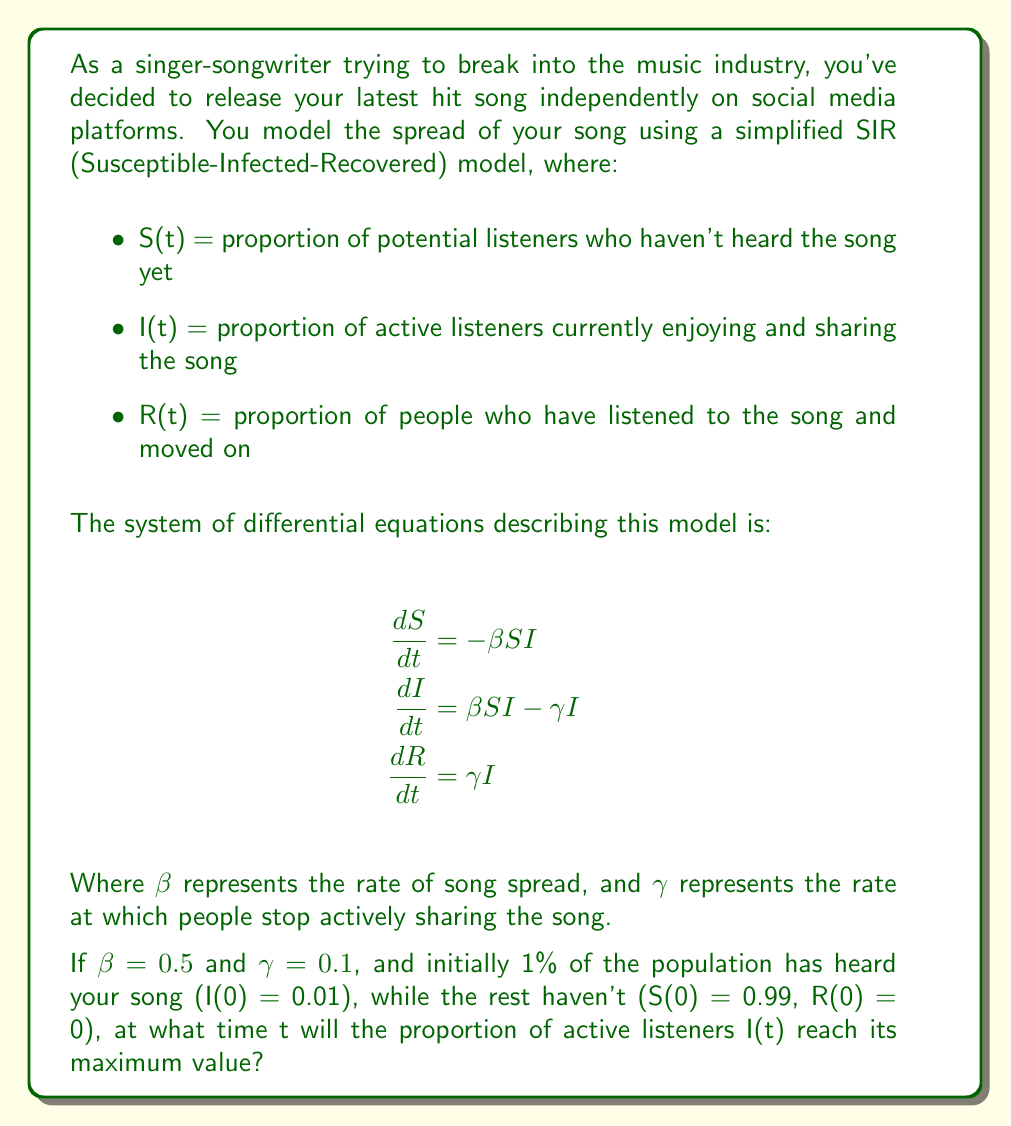Teach me how to tackle this problem. To solve this problem, we need to find when dI/dt = 0, as this indicates the point where I(t) reaches its maximum value.

1) First, we set the equation for dI/dt to zero:

   $$\beta S I - \gamma I = 0$$

2) Factor out I:

   $$I(\beta S - \gamma) = 0$$

3) Since we're interested in the non-trivial solution where I ≠ 0, we solve:

   $$\beta S - \gamma = 0$$

4) Rearrange to solve for S:

   $$S = \frac{\gamma}{\beta} = \frac{0.1}{0.5} = 0.2$$

5) This means that I(t) reaches its maximum when S(t) = 0.2. To find when this occurs, we need to use the conservation of total population:

   $$S(t) + I(t) + R(t) = 1$$

6) At the peak of I(t), we know S(t) = 0.2, so:

   $$0.2 + I_{max} + R = 1$$

7) We can find R by integrating dR/dt from 0 to t:

   $$R = \gamma \int_0^t I(t) dt = 1 - S = 1 - 0.2 = 0.8$$

8) Substituting this back:

   $$0.2 + I_{max} + 0.8 = 1$$
   $$I_{max} = 0.8$$

9) To find the time t when this occurs, we can use the equation for dS/dt:

   $$\frac{dS}{dt} = -\beta S I$$

   Integrating both sides from 0 to t:

   $$\int_{0.99}^{0.2} \frac{dS}{S} = -\beta \int_0^t I(t) dt$$

   $$\ln(0.2) - \ln(0.99) = -0.5 \cdot 0.8$$

10) Solving for t:

    $$t = \frac{\ln(0.99) - \ln(0.2)}{0.5 \cdot 0.8} \approx 3.97$$

Therefore, I(t) reaches its maximum value at approximately t = 3.97 time units.
Answer: The proportion of active listeners I(t) reaches its maximum value at approximately t = 3.97 time units. 